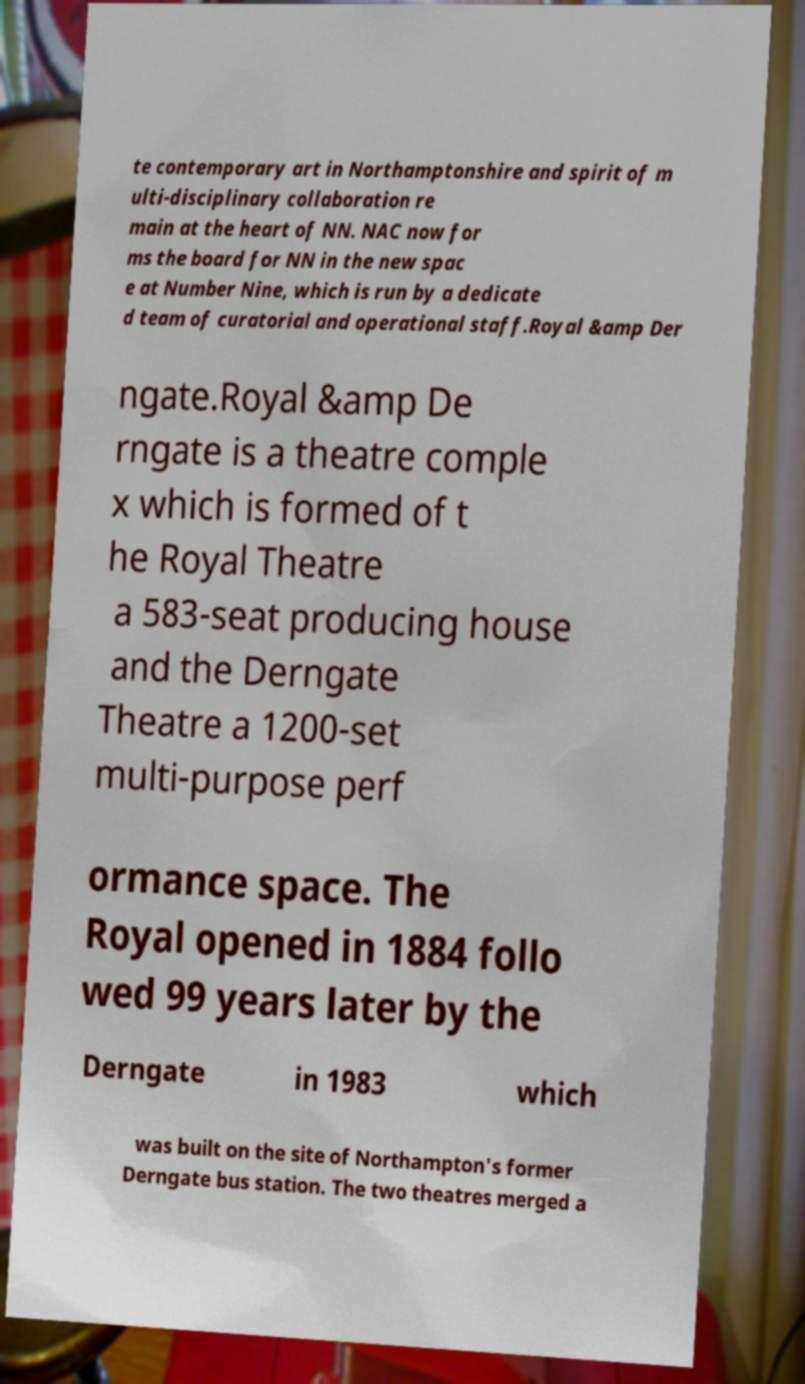Please identify and transcribe the text found in this image. te contemporary art in Northamptonshire and spirit of m ulti-disciplinary collaboration re main at the heart of NN. NAC now for ms the board for NN in the new spac e at Number Nine, which is run by a dedicate d team of curatorial and operational staff.Royal &amp Der ngate.Royal &amp De rngate is a theatre comple x which is formed of t he Royal Theatre a 583-seat producing house and the Derngate Theatre a 1200-set multi-purpose perf ormance space. The Royal opened in 1884 follo wed 99 years later by the Derngate in 1983 which was built on the site of Northampton's former Derngate bus station. The two theatres merged a 